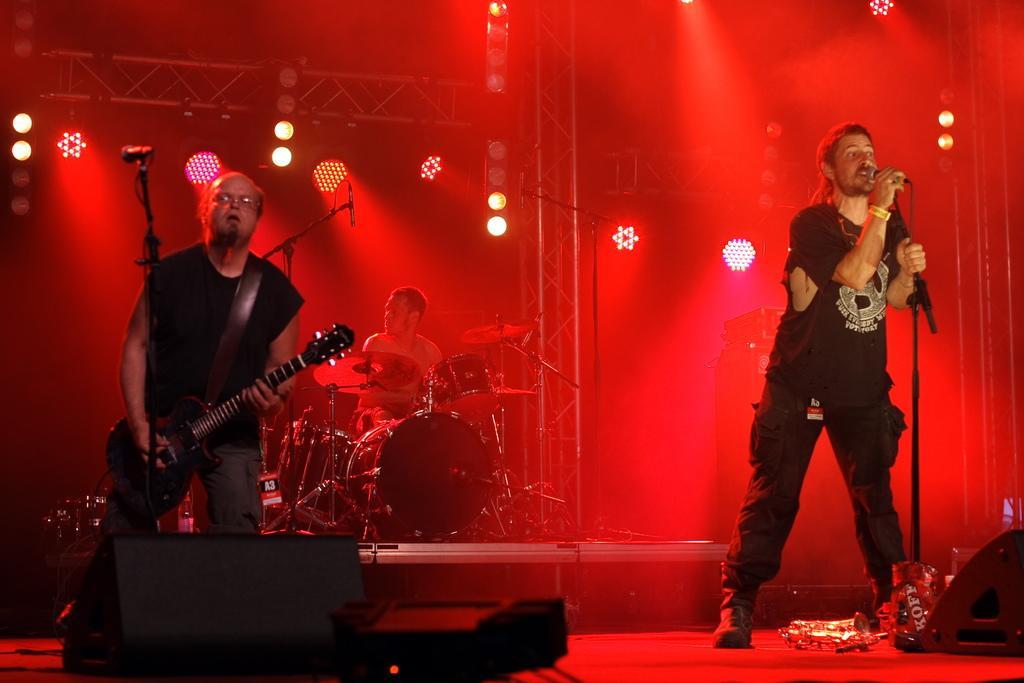Describe this image in one or two sentences. In this picture we can see two persons standing in front of mike. He is playing guitar and he is singing on the mike. On the background we can see a man who is playing drums. And these are the lights. 